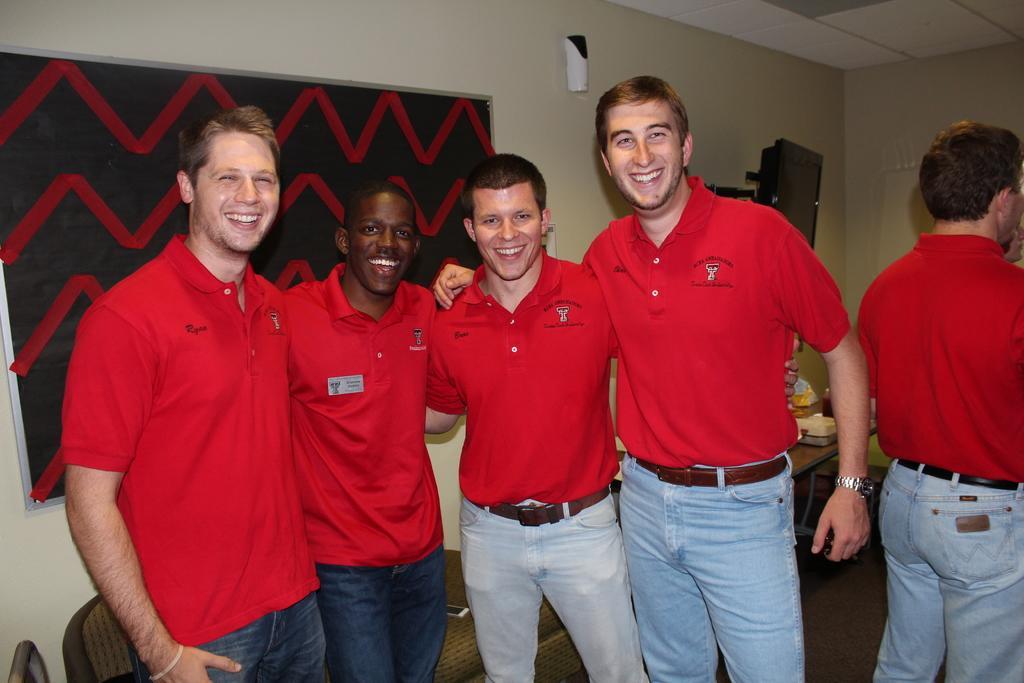Describe this image in one or two sentences. In the image we can see there are men standing and they are wearing red colour t shirt. Behind there is a board kept on the wall and there are other items kept on the ground. 